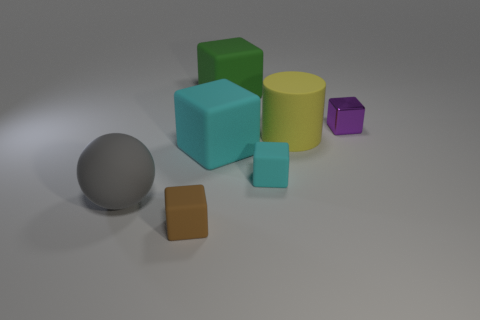Subtract all small cyan blocks. How many blocks are left? 4 Add 2 small brown objects. How many objects exist? 9 Subtract all cyan blocks. How many blocks are left? 3 Subtract all cylinders. How many objects are left? 6 Subtract 1 blocks. How many blocks are left? 4 Subtract all yellow cubes. How many blue cylinders are left? 0 Subtract all brown matte cubes. Subtract all rubber balls. How many objects are left? 5 Add 5 big matte cylinders. How many big matte cylinders are left? 6 Add 4 small purple metallic cubes. How many small purple metallic cubes exist? 5 Subtract 0 red cylinders. How many objects are left? 7 